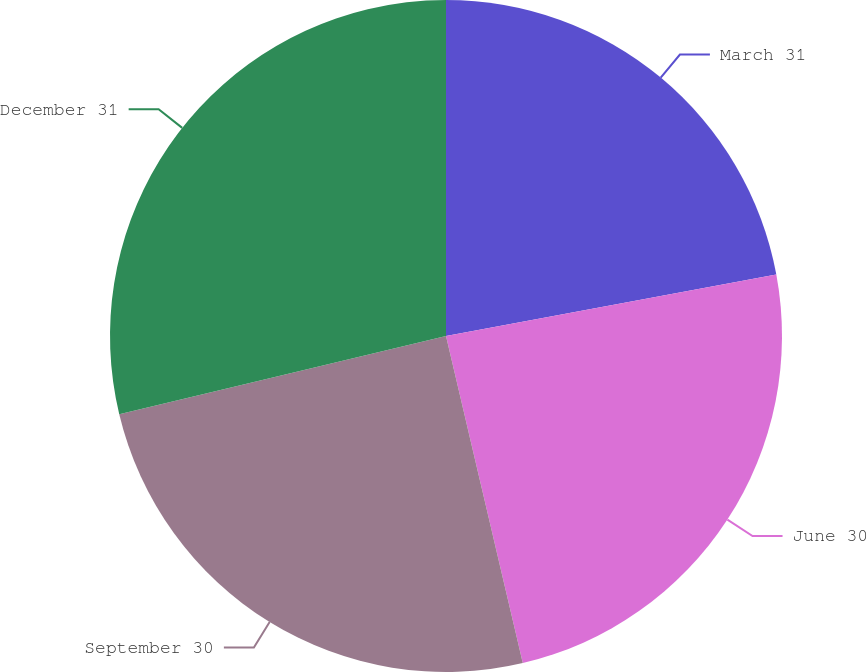<chart> <loc_0><loc_0><loc_500><loc_500><pie_chart><fcel>March 31<fcel>June 30<fcel>September 30<fcel>December 31<nl><fcel>22.07%<fcel>24.26%<fcel>24.93%<fcel>28.74%<nl></chart> 